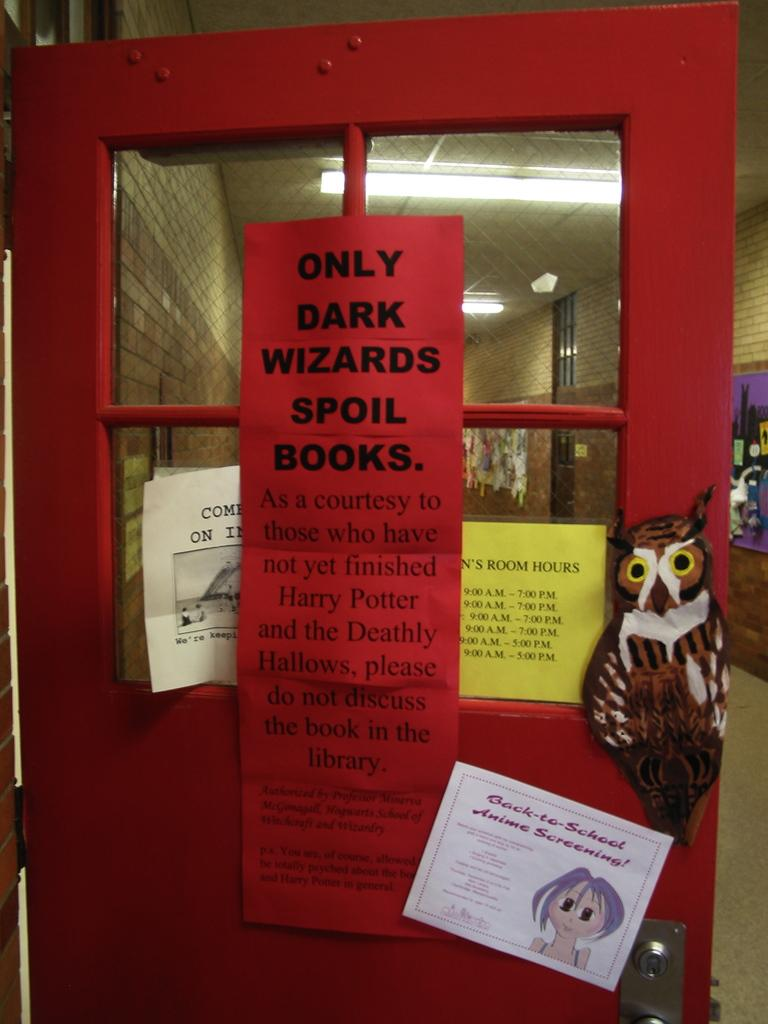<image>
Relay a brief, clear account of the picture shown. A red door with a sign that reads only dark wizards spoil books. 